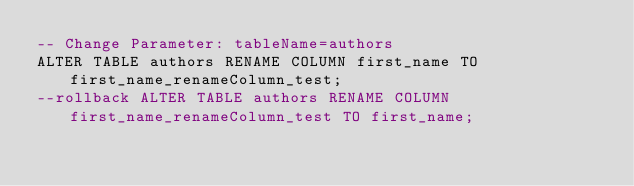<code> <loc_0><loc_0><loc_500><loc_500><_SQL_>-- Change Parameter: tableName=authors
ALTER TABLE authors RENAME COLUMN first_name TO first_name_renameColumn_test;
--rollback ALTER TABLE authors RENAME COLUMN first_name_renameColumn_test TO first_name;
</code> 